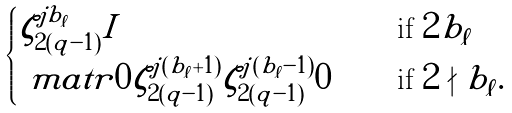Convert formula to latex. <formula><loc_0><loc_0><loc_500><loc_500>\begin{cases} \zeta _ { 2 ( q - 1 ) } ^ { j b _ { \ell } } I & \quad \text { if } 2 | b _ { \ell } \\ \ m a t r { 0 } { \zeta _ { 2 ( q - 1 ) } ^ { j ( b _ { \ell } + 1 ) } } { \zeta _ { 2 ( q - 1 ) } ^ { j ( b _ { \ell } - 1 ) } } { 0 } & \quad \text { if } 2 \nmid b _ { \ell } . \end{cases}</formula> 